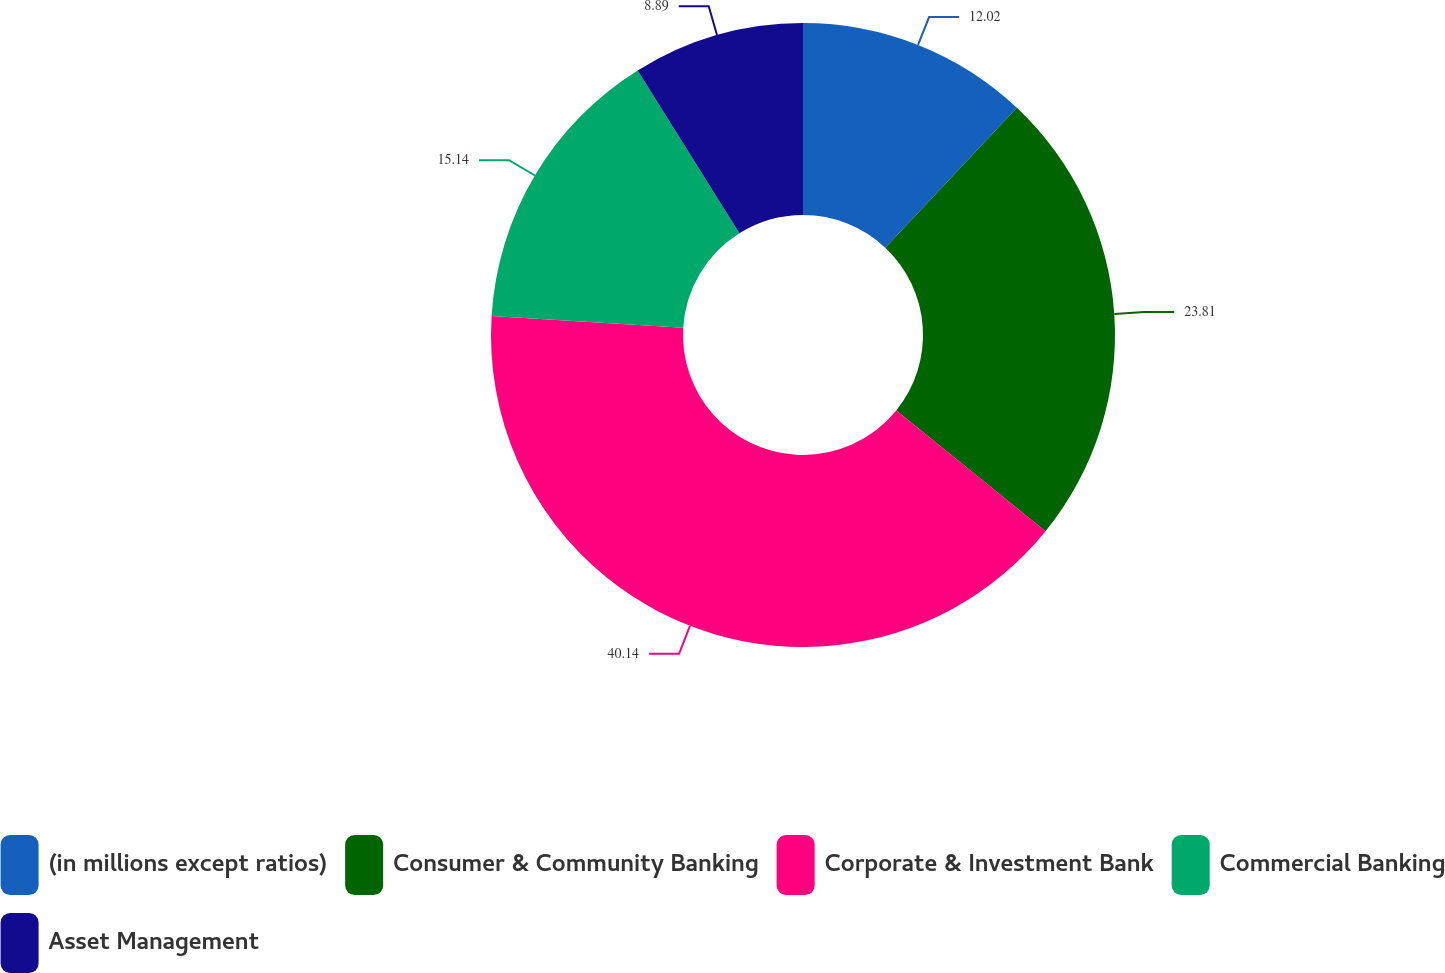Convert chart to OTSL. <chart><loc_0><loc_0><loc_500><loc_500><pie_chart><fcel>(in millions except ratios)<fcel>Consumer & Community Banking<fcel>Corporate & Investment Bank<fcel>Commercial Banking<fcel>Asset Management<nl><fcel>12.02%<fcel>23.81%<fcel>40.14%<fcel>15.14%<fcel>8.89%<nl></chart> 